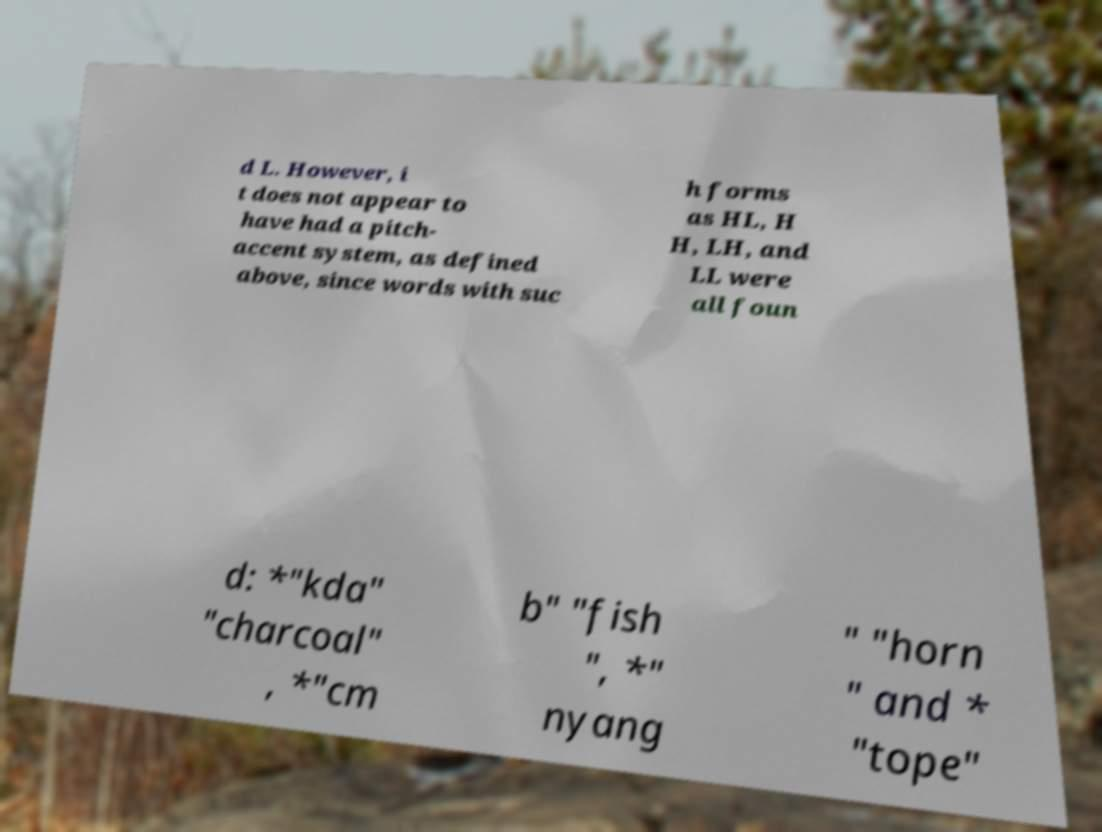Could you extract and type out the text from this image? d L. However, i t does not appear to have had a pitch- accent system, as defined above, since words with suc h forms as HL, H H, LH, and LL were all foun d: *"kda" "charcoal" , *"cm b" "fish ", *" nyang " "horn " and * "tope" 